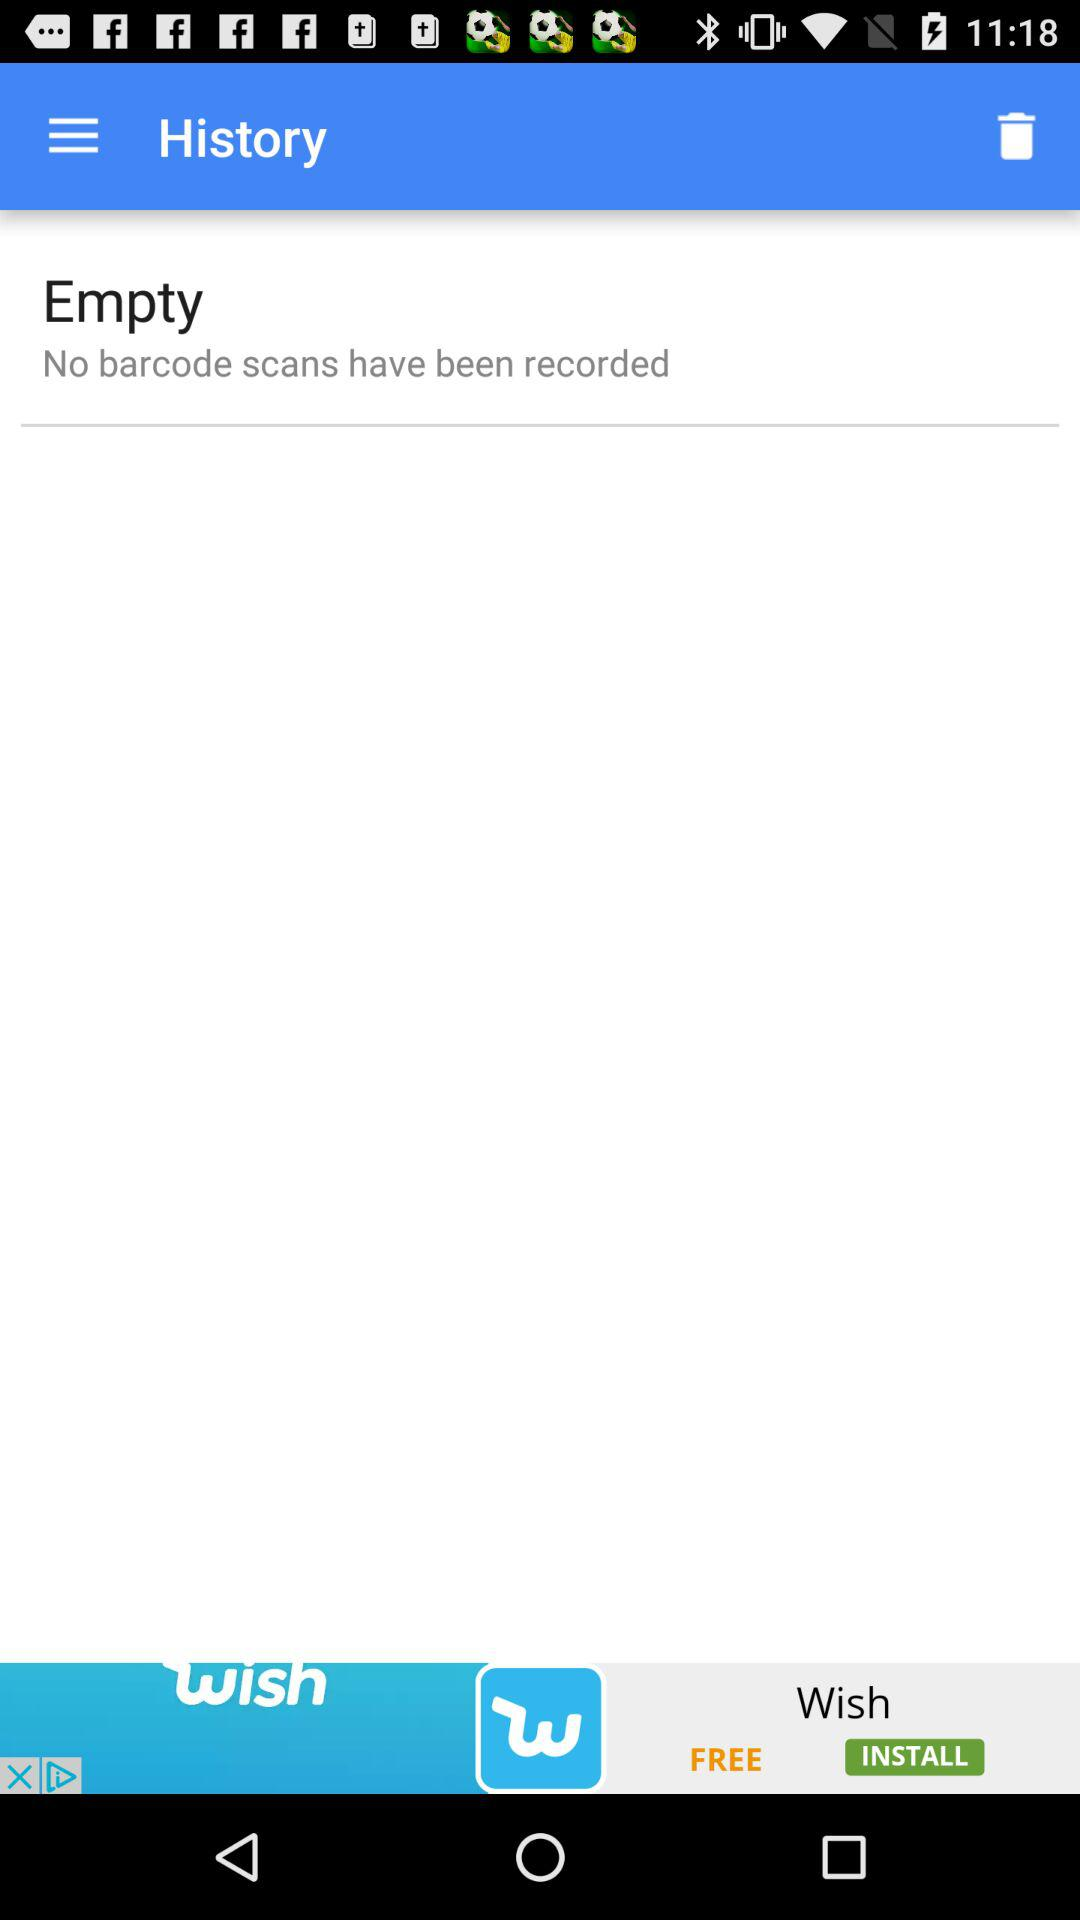What is the total number of barcode scans that have been recorded? There are no barcode scans that have been recorded. 